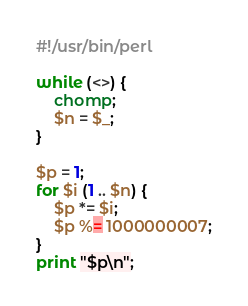Convert code to text. <code><loc_0><loc_0><loc_500><loc_500><_Perl_>#!/usr/bin/perl

while (<>) {
    chomp;
    $n = $_;
}

$p = 1;
for $i (1 .. $n) {
    $p *= $i;
    $p %= 1000000007;
}
print "$p\n";
</code> 